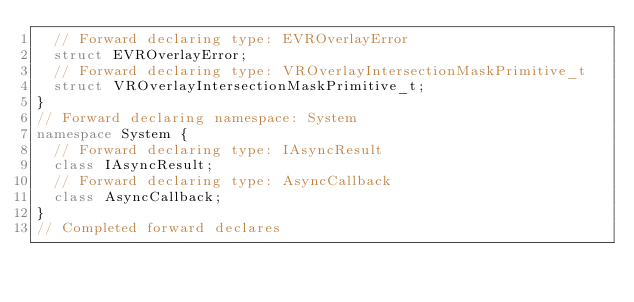Convert code to text. <code><loc_0><loc_0><loc_500><loc_500><_C++_>  // Forward declaring type: EVROverlayError
  struct EVROverlayError;
  // Forward declaring type: VROverlayIntersectionMaskPrimitive_t
  struct VROverlayIntersectionMaskPrimitive_t;
}
// Forward declaring namespace: System
namespace System {
  // Forward declaring type: IAsyncResult
  class IAsyncResult;
  // Forward declaring type: AsyncCallback
  class AsyncCallback;
}
// Completed forward declares</code> 